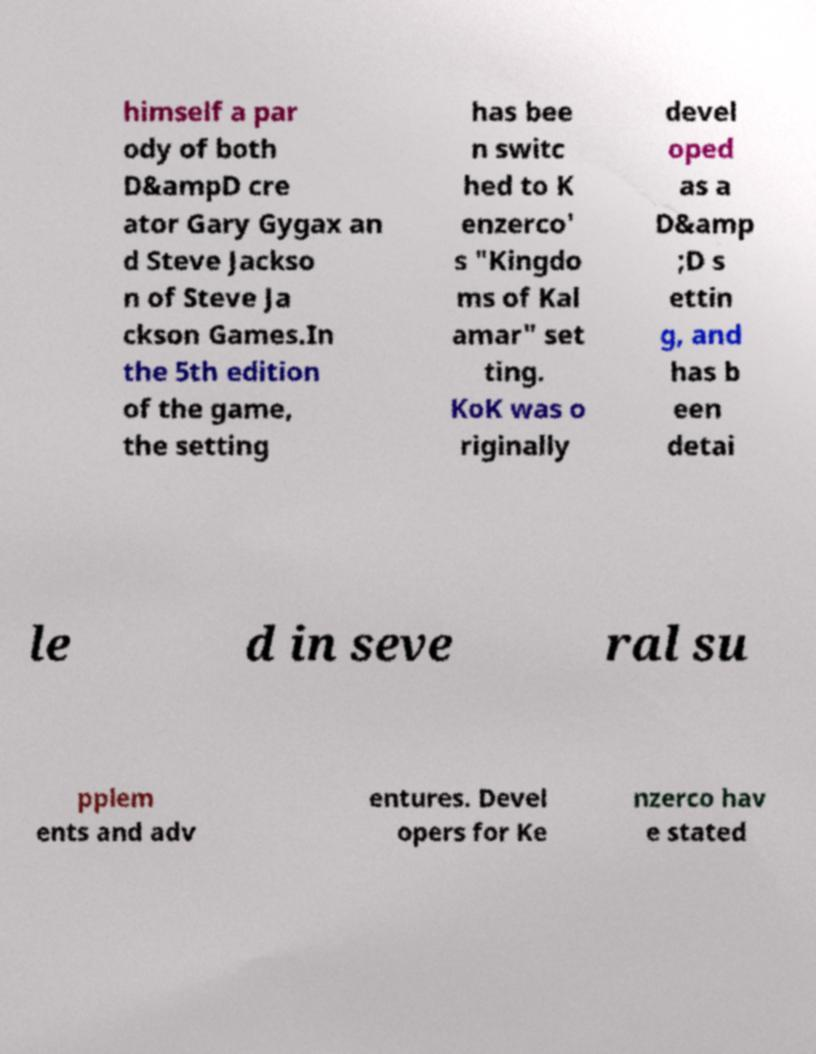Could you extract and type out the text from this image? himself a par ody of both D&ampD cre ator Gary Gygax an d Steve Jackso n of Steve Ja ckson Games.In the 5th edition of the game, the setting has bee n switc hed to K enzerco' s "Kingdo ms of Kal amar" set ting. KoK was o riginally devel oped as a D&amp ;D s ettin g, and has b een detai le d in seve ral su pplem ents and adv entures. Devel opers for Ke nzerco hav e stated 